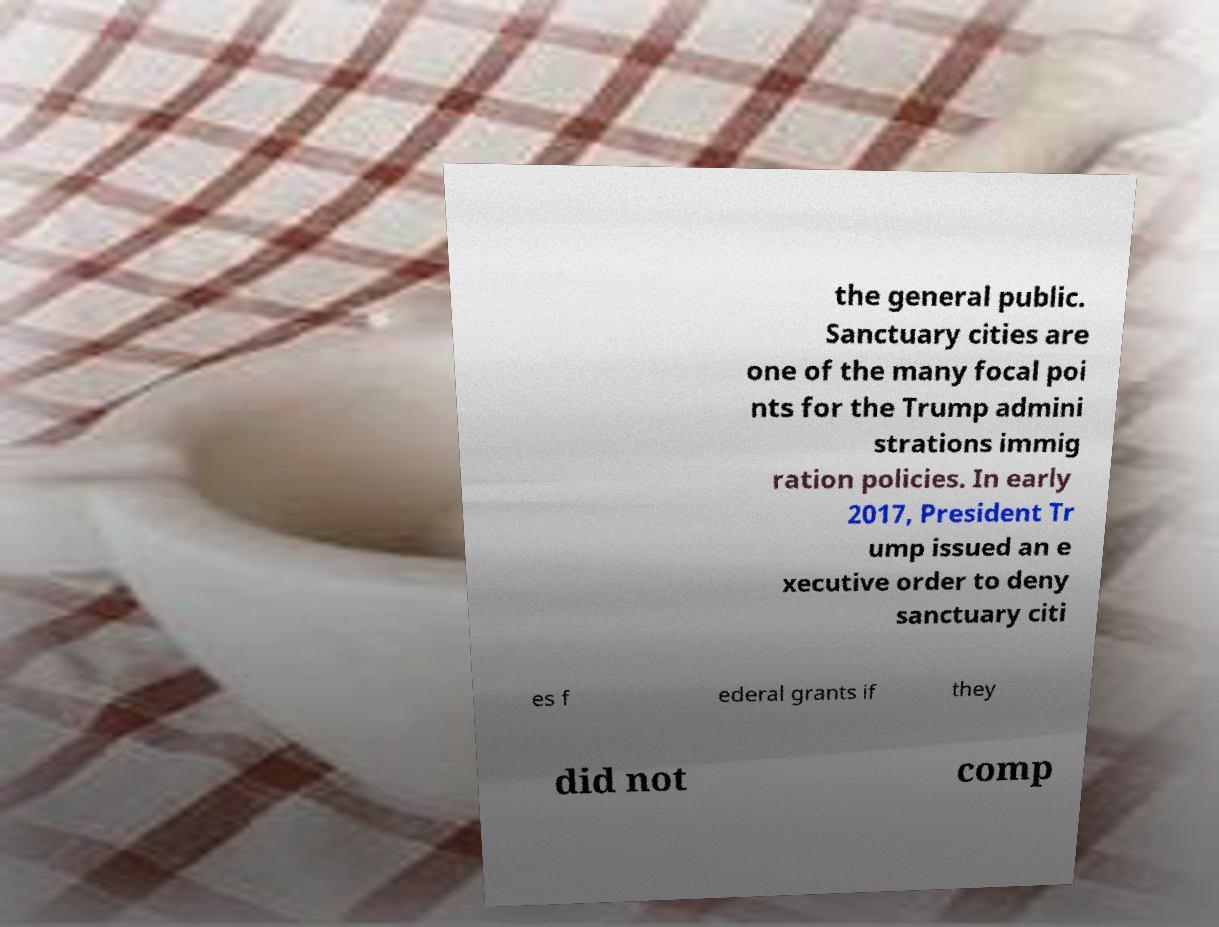Can you read and provide the text displayed in the image?This photo seems to have some interesting text. Can you extract and type it out for me? the general public. Sanctuary cities are one of the many focal poi nts for the Trump admini strations immig ration policies. In early 2017, President Tr ump issued an e xecutive order to deny sanctuary citi es f ederal grants if they did not comp 